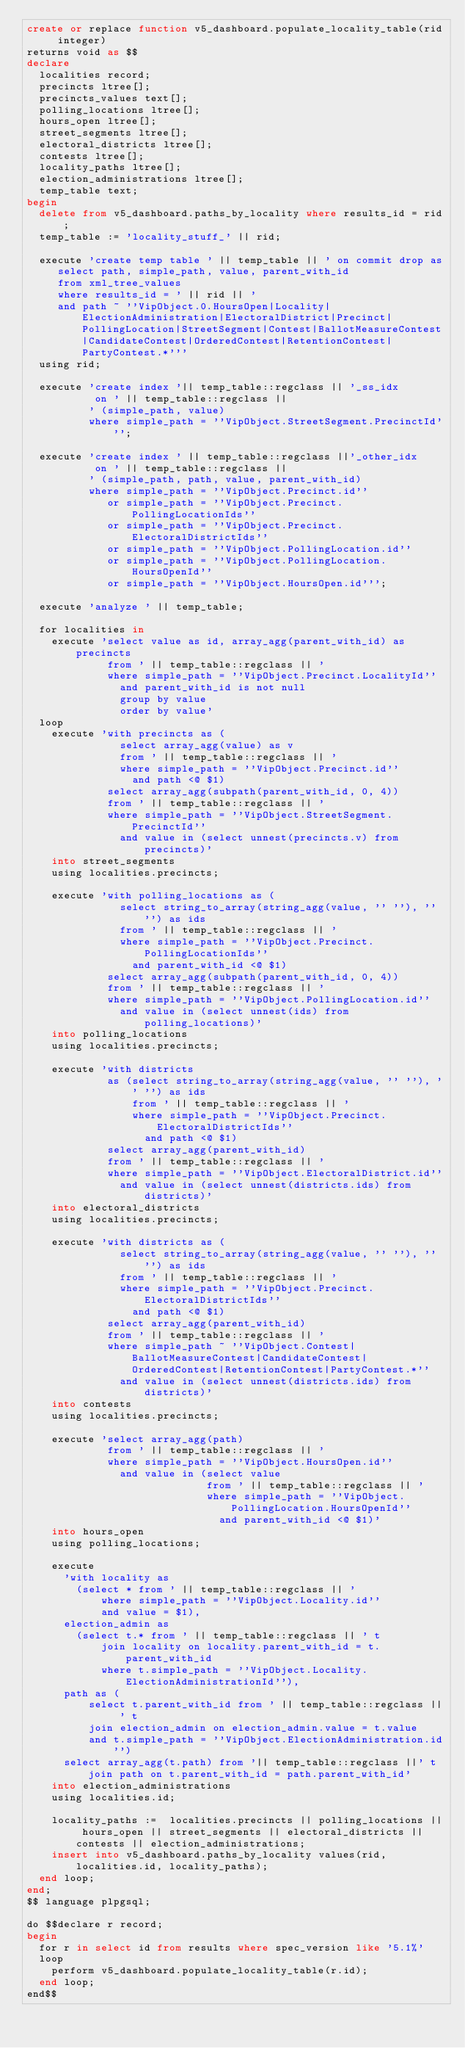Convert code to text. <code><loc_0><loc_0><loc_500><loc_500><_SQL_>create or replace function v5_dashboard.populate_locality_table(rid integer)
returns void as $$
declare
  localities record;
  precincts ltree[];
  precincts_values text[];
  polling_locations ltree[];
  hours_open ltree[];
  street_segments ltree[];
  electoral_districts ltree[];
  contests ltree[];
  locality_paths ltree[];
  election_administrations ltree[];
  temp_table text;
begin
  delete from v5_dashboard.paths_by_locality where results_id = rid;
  temp_table := 'locality_stuff_' || rid;

  execute 'create temp table ' || temp_table || ' on commit drop as
     select path, simple_path, value, parent_with_id
     from xml_tree_values
     where results_id = ' || rid || '
     and path ~ ''VipObject.0.HoursOpen|Locality|ElectionAdministration|ElectoralDistrict|Precinct|PollingLocation|StreetSegment|Contest|BallotMeasureContest|CandidateContest|OrderedContest|RetentionContest|PartyContest.*'''
  using rid;

  execute 'create index '|| temp_table::regclass || '_ss_idx
           on ' || temp_table::regclass ||
          ' (simple_path, value)
          where simple_path = ''VipObject.StreetSegment.PrecinctId''';

  execute 'create index ' || temp_table::regclass ||'_other_idx
           on ' || temp_table::regclass ||
          ' (simple_path, path, value, parent_with_id)
          where simple_path = ''VipObject.Precinct.id''
             or simple_path = ''VipObject.Precinct.PollingLocationIds''
             or simple_path = ''VipObject.Precinct.ElectoralDistrictIds''
             or simple_path = ''VipObject.PollingLocation.id''
             or simple_path = ''VipObject.PollingLocation.HoursOpenId''
             or simple_path = ''VipObject.HoursOpen.id''';

  execute 'analyze ' || temp_table;

  for localities in
    execute 'select value as id, array_agg(parent_with_id) as precincts
             from ' || temp_table::regclass || '
             where simple_path = ''VipObject.Precinct.LocalityId''
               and parent_with_id is not null
               group by value
               order by value'
  loop
    execute 'with precincts as (
               select array_agg(value) as v
               from ' || temp_table::regclass || '
               where simple_path = ''VipObject.Precinct.id''
                 and path <@ $1)
             select array_agg(subpath(parent_with_id, 0, 4))
             from ' || temp_table::regclass || '
             where simple_path = ''VipObject.StreetSegment.PrecinctId''
               and value in (select unnest(precincts.v) from precincts)'
    into street_segments
    using localities.precincts;

    execute 'with polling_locations as (
               select string_to_array(string_agg(value, '' ''), '' '') as ids
               from ' || temp_table::regclass || '
               where simple_path = ''VipObject.Precinct.PollingLocationIds''
                 and parent_with_id <@ $1)
             select array_agg(subpath(parent_with_id, 0, 4))
             from ' || temp_table::regclass || '
             where simple_path = ''VipObject.PollingLocation.id''
               and value in (select unnest(ids) from polling_locations)'
    into polling_locations
    using localities.precincts;

    execute 'with districts
             as (select string_to_array(string_agg(value, '' ''), '' '') as ids
                 from ' || temp_table::regclass || '
                 where simple_path = ''VipObject.Precinct.ElectoralDistrictIds''
                   and path <@ $1)
             select array_agg(parent_with_id)
             from ' || temp_table::regclass || '
             where simple_path = ''VipObject.ElectoralDistrict.id''
               and value in (select unnest(districts.ids) from districts)'
    into electoral_districts
    using localities.precincts;

    execute 'with districts as (
               select string_to_array(string_agg(value, '' ''), '' '') as ids
               from ' || temp_table::regclass || '
               where simple_path = ''VipObject.Precinct.ElectoralDistrictIds''
                 and path <@ $1)
             select array_agg(parent_with_id)
             from ' || temp_table::regclass || '
             where simple_path ~ ''VipObject.Contest|BallotMeasureContest|CandidateContest|OrderedContest|RetentionContest|PartyContest.*''
               and value in (select unnest(districts.ids) from districts)'
    into contests
    using localities.precincts;

    execute 'select array_agg(path)
             from ' || temp_table::regclass || '
             where simple_path = ''VipObject.HoursOpen.id''
               and value in (select value
                             from ' || temp_table::regclass || '
                             where simple_path = ''VipObject.PollingLocation.HoursOpenId''
                               and parent_with_id <@ $1)'
    into hours_open
    using polling_locations;

    execute
      'with locality as
        (select * from ' || temp_table::regclass || '
            where simple_path = ''VipObject.Locality.id''
            and value = $1),
      election_admin as
        (select t.* from ' || temp_table::regclass || ' t
            join locality on locality.parent_with_id = t.parent_with_id
            where t.simple_path = ''VipObject.Locality.ElectionAdministrationId''),
      path as (
          select t.parent_with_id from ' || temp_table::regclass || ' t
          join election_admin on election_admin.value = t.value
          and t.simple_path = ''VipObject.ElectionAdministration.id'')
      select array_agg(t.path) from '|| temp_table::regclass ||' t join path on t.parent_with_id = path.parent_with_id'
    into election_administrations
    using localities.id;

    locality_paths :=  localities.precincts || polling_locations || hours_open || street_segments || electoral_districts || contests || election_administrations;
    insert into v5_dashboard.paths_by_locality values(rid, localities.id, locality_paths);
  end loop;
end;
$$ language plpgsql;

do $$declare r record;
begin
  for r in select id from results where spec_version like '5.1%'
  loop
    perform v5_dashboard.populate_locality_table(r.id);
  end loop;
end$$
</code> 